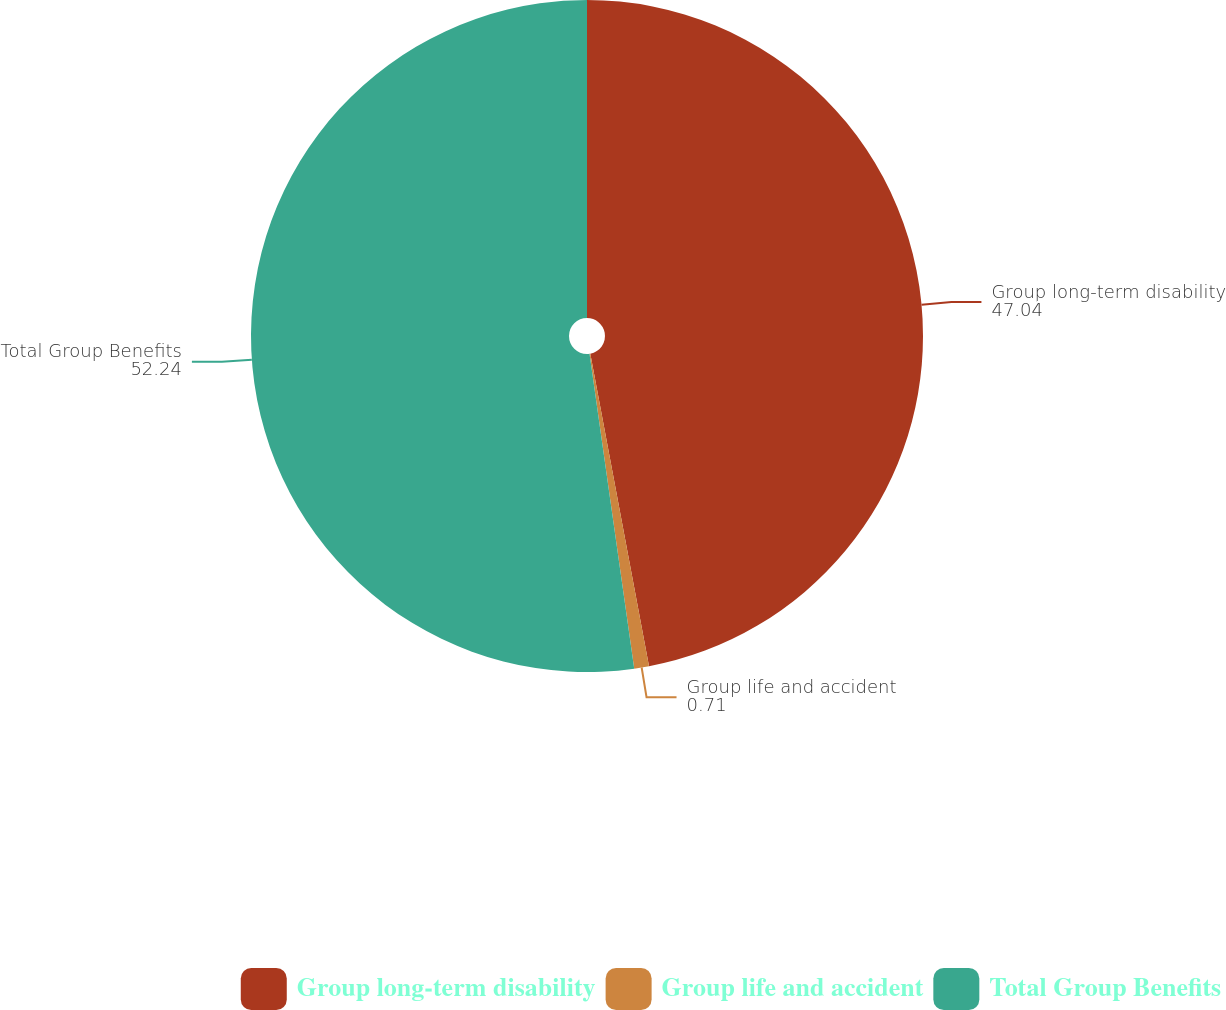Convert chart to OTSL. <chart><loc_0><loc_0><loc_500><loc_500><pie_chart><fcel>Group long-term disability<fcel>Group life and accident<fcel>Total Group Benefits<nl><fcel>47.04%<fcel>0.71%<fcel>52.24%<nl></chart> 